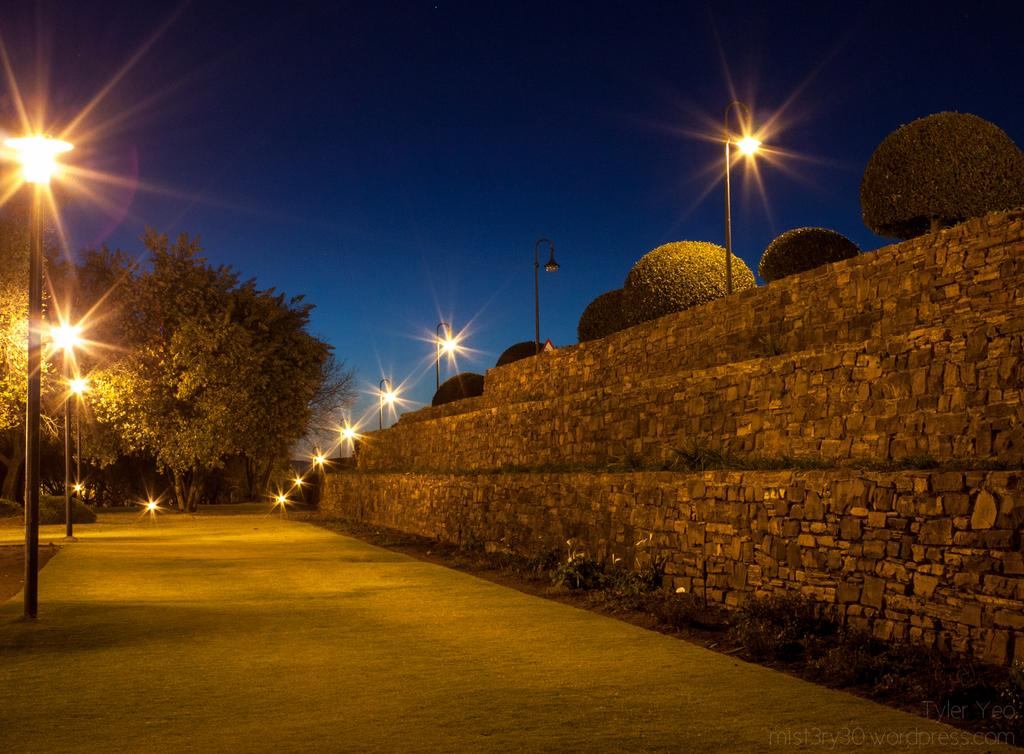What is the main feature in the middle of the image? There is a road in the middle of the image. What structures are present alongside the road? There are street lights on either side of the road. What can be seen in the background of the image? There are trees visible in the background of the image. What is visible above the road and trees? The sky is visible in the image. Where is the queen standing in the image? There is no queen present in the image. What type of farm animals can be seen grazing on the side of the road? There are no farm animals or any indication of a farm in the image. 